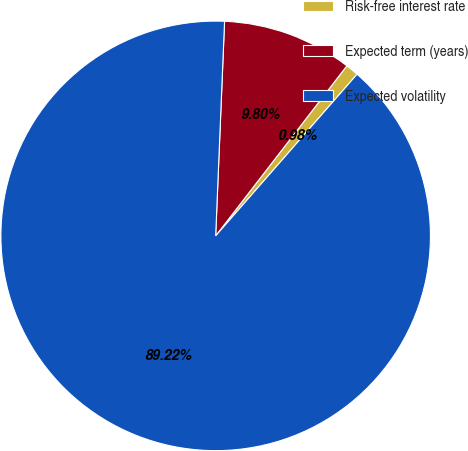Convert chart. <chart><loc_0><loc_0><loc_500><loc_500><pie_chart><fcel>Risk-free interest rate<fcel>Expected term (years)<fcel>Expected volatility<nl><fcel>0.98%<fcel>9.8%<fcel>89.22%<nl></chart> 